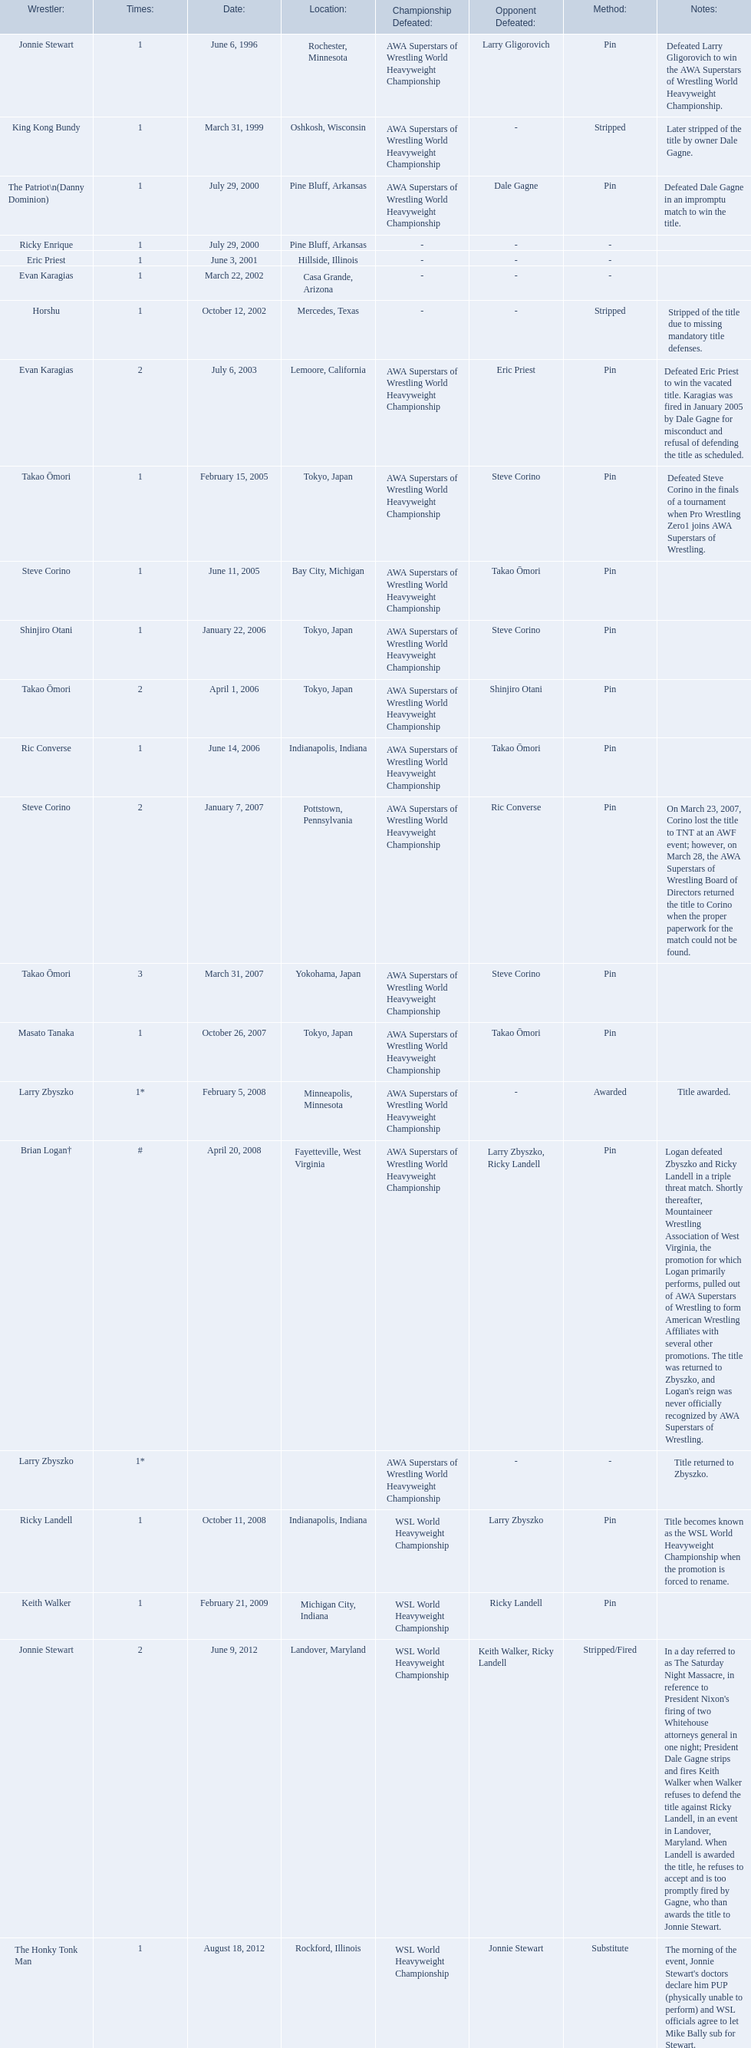Who are the wrestlers? Jonnie Stewart, Rochester, Minnesota, King Kong Bundy, Oshkosh, Wisconsin, The Patriot\n(Danny Dominion), Pine Bluff, Arkansas, Ricky Enrique, Pine Bluff, Arkansas, Eric Priest, Hillside, Illinois, Evan Karagias, Casa Grande, Arizona, Horshu, Mercedes, Texas, Evan Karagias, Lemoore, California, Takao Ōmori, Tokyo, Japan, Steve Corino, Bay City, Michigan, Shinjiro Otani, Tokyo, Japan, Takao Ōmori, Tokyo, Japan, Ric Converse, Indianapolis, Indiana, Steve Corino, Pottstown, Pennsylvania, Takao Ōmori, Yokohama, Japan, Masato Tanaka, Tokyo, Japan, Larry Zbyszko, Minneapolis, Minnesota, Brian Logan†, Fayetteville, West Virginia, Larry Zbyszko, , Ricky Landell, Indianapolis, Indiana, Keith Walker, Michigan City, Indiana, Jonnie Stewart, Landover, Maryland, The Honky Tonk Man, Rockford, Illinois. Who was from texas? Horshu, Mercedes, Texas. Who is he? Horshu. 